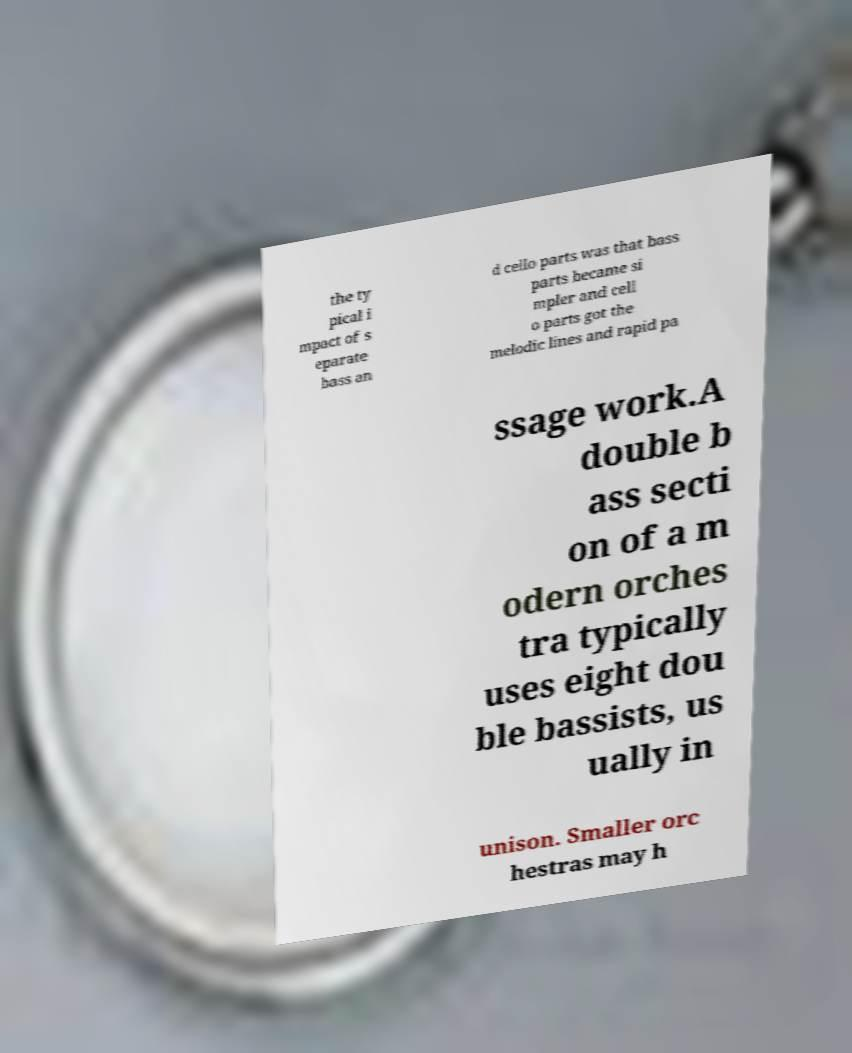For documentation purposes, I need the text within this image transcribed. Could you provide that? the ty pical i mpact of s eparate bass an d cello parts was that bass parts became si mpler and cell o parts got the melodic lines and rapid pa ssage work.A double b ass secti on of a m odern orches tra typically uses eight dou ble bassists, us ually in unison. Smaller orc hestras may h 